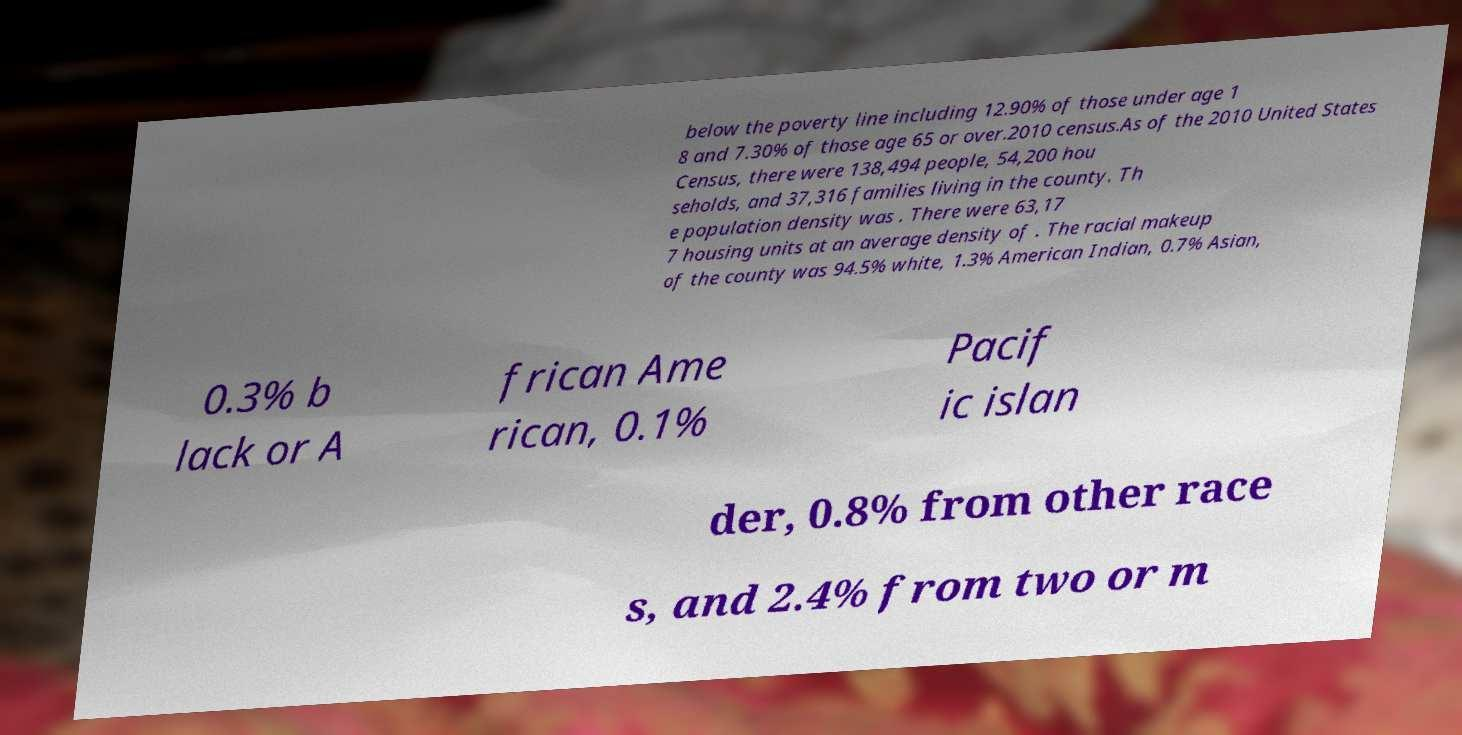Could you extract and type out the text from this image? below the poverty line including 12.90% of those under age 1 8 and 7.30% of those age 65 or over.2010 census.As of the 2010 United States Census, there were 138,494 people, 54,200 hou seholds, and 37,316 families living in the county. Th e population density was . There were 63,17 7 housing units at an average density of . The racial makeup of the county was 94.5% white, 1.3% American Indian, 0.7% Asian, 0.3% b lack or A frican Ame rican, 0.1% Pacif ic islan der, 0.8% from other race s, and 2.4% from two or m 